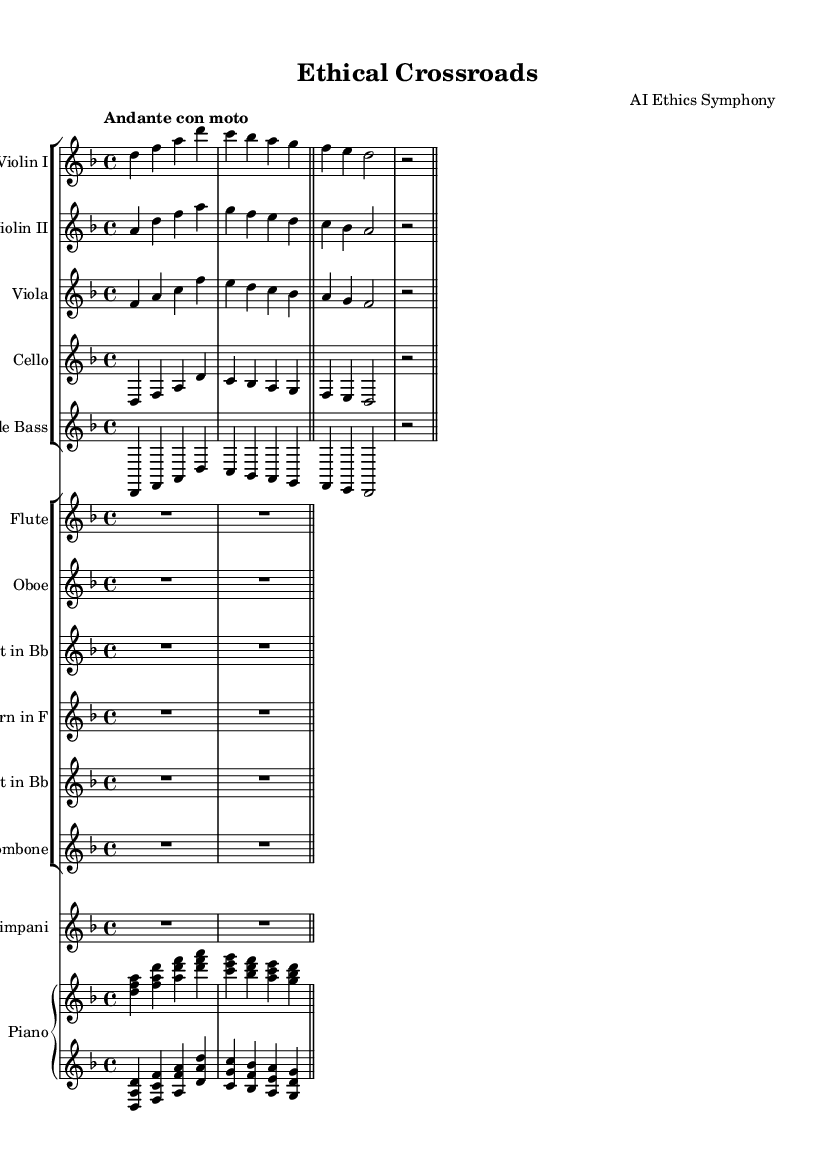What is the key signature of this music? The key signature is D minor, which has one flat. This can be determined from the beginning of the score, where the key signature is indicated.
Answer: D minor What is the time signature of this sheet music? The time signature is 4/4, which is shown at the beginning of the score. It indicates that there are four beats per measure, and the quarter note gets one beat.
Answer: 4/4 What is the tempo marking for this symphony? The tempo marking is "Andante con moto". This indicates a moderate pace with a sense of movement. Tempo markings are usually written at the beginning of the music above the staff.
Answer: Andante con moto Which instruments are featured in this symphony? The symphony features strings and woodwinds, including violins, viola, cello, double bass, flute, oboe, clarinet, horn, trumpet, trombone, timpani, and piano. This can be determined by the presence of specific staves for each instrument group throughout the sheet music.
Answer: Strings and woodwinds What role does the piano play in this piece? The piano has both a right hand (RH) and left hand (LH) part, indicating a harmonic and rhythmic foundation. Each hand plays different chords and melodies that complement the orchestral texture. This can be found by examining the designated staves for the piano within the score.
Answer: Harmonic and rhythmic foundation How many measures are present in each instrumental part? Each instrumental part includes two measures, as indicated by the bar lines that segment the music notation. These lines denote the end of a measure, and the notation in the score shows that each part ends with a double bar line, confirming two measures.
Answer: 2 measures 